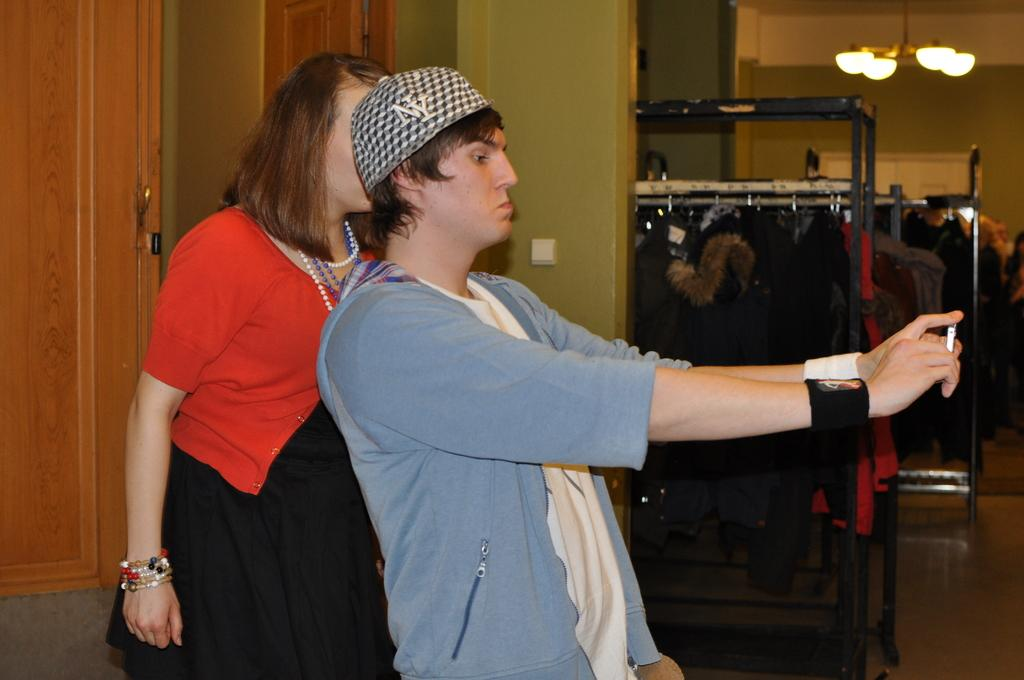What is the main subject of the image? There is a person standing in the image. What is the person holding in the image? The person is holding an object. Can you describe the other person in the image? There is a woman standing behind the person. What can be seen in the background of the image? There are clothes visible in the background of the image. What type of wren can be seen perched on the person's leg in the image? There is no wren present in the image, and the person's leg is not mentioned in the facts. --- Facts: 1. There is a car in the image. 2. The car is parked on the street. 3. There are trees on both sides of the street. 4. The sky is visible in the image. Absurd Topics: parrot, bicycle, fence Conversation: What is the main subject of the image? There is a car in the image. Where is the car located in the image? The car is parked on the street. What can be seen on both sides of the street in the image? There are trees on both sides of the street. What is visible in the background of the image? The sky is visible in the image. Reasoning: Let's think step by step in order to produce the conversation. We start by identifying the main subject of the image, which is the car. Then, we describe the location of the car, which is parked on the street. Next, we mention the trees on both sides of the street, as they are mentioned in the facts. Finally, we acknowledge the presence of the sky in the background of the image. Absurd Question/Answer: Can you tell me how many parrots are sitting on the car's roof in the image? There are no parrots present in the image, and the car's roof is not mentioned in the facts. --- Facts: 1. There is a group of people in the image. 2. The people are sitting on the ground. 3. There is a picnic blanket under the people. 4. There are food items visible in the image. Absurd Topics: elephant, hat, mountain Conversation: What is the main subject of the image? There is a group of people in the image. What are the people doing in the image? The people are sitting on the ground. What is under the people in the image? There is a picnic blanket under the people. What else can be seen in the image besides the people? There are food items visible in the image. Reasoning: Let's think step by step in order to produce the conversation. We start by identifying the main subject of the image, which is the group of people. Then, we describe what the people are doing 